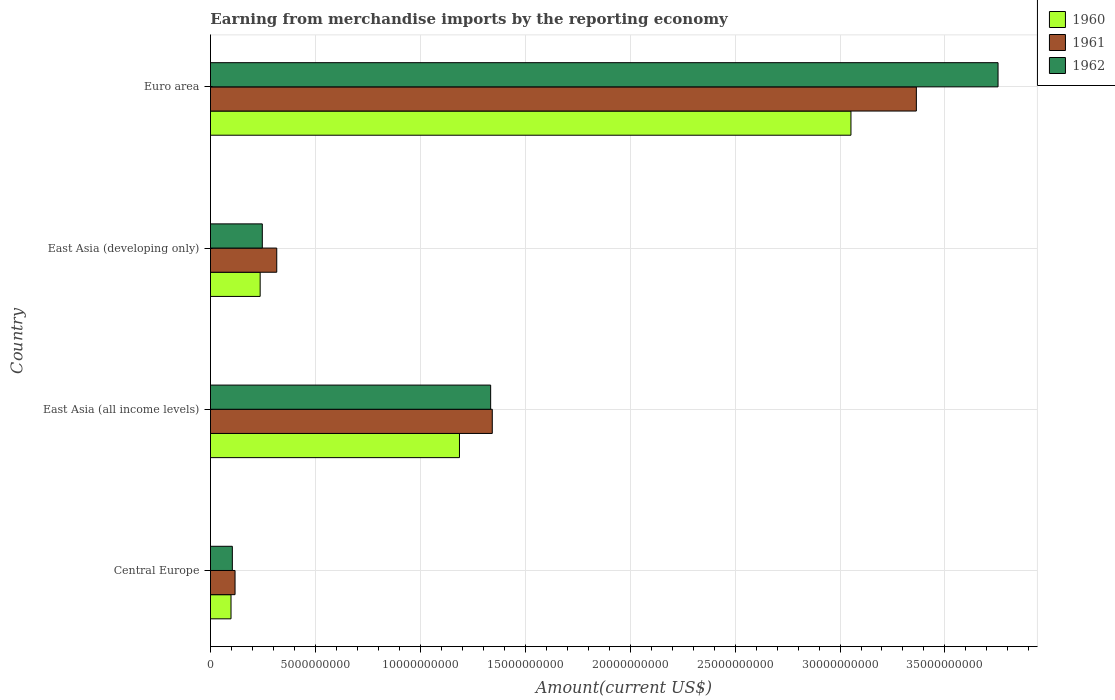How many groups of bars are there?
Provide a succinct answer. 4. How many bars are there on the 4th tick from the top?
Keep it short and to the point. 3. What is the label of the 4th group of bars from the top?
Make the answer very short. Central Europe. What is the amount earned from merchandise imports in 1961 in Euro area?
Ensure brevity in your answer.  3.36e+1. Across all countries, what is the maximum amount earned from merchandise imports in 1960?
Your answer should be compact. 3.05e+1. Across all countries, what is the minimum amount earned from merchandise imports in 1961?
Provide a short and direct response. 1.17e+09. In which country was the amount earned from merchandise imports in 1961 maximum?
Your response must be concise. Euro area. In which country was the amount earned from merchandise imports in 1960 minimum?
Keep it short and to the point. Central Europe. What is the total amount earned from merchandise imports in 1960 in the graph?
Give a very brief answer. 4.57e+1. What is the difference between the amount earned from merchandise imports in 1962 in East Asia (all income levels) and that in East Asia (developing only)?
Make the answer very short. 1.09e+1. What is the difference between the amount earned from merchandise imports in 1962 in Euro area and the amount earned from merchandise imports in 1961 in East Asia (developing only)?
Your answer should be compact. 3.44e+1. What is the average amount earned from merchandise imports in 1962 per country?
Give a very brief answer. 1.36e+1. What is the difference between the amount earned from merchandise imports in 1962 and amount earned from merchandise imports in 1961 in East Asia (all income levels)?
Ensure brevity in your answer.  -7.72e+07. In how many countries, is the amount earned from merchandise imports in 1961 greater than 23000000000 US$?
Provide a short and direct response. 1. What is the ratio of the amount earned from merchandise imports in 1961 in Central Europe to that in East Asia (all income levels)?
Your answer should be compact. 0.09. Is the amount earned from merchandise imports in 1961 in Central Europe less than that in East Asia (all income levels)?
Keep it short and to the point. Yes. Is the difference between the amount earned from merchandise imports in 1962 in Central Europe and Euro area greater than the difference between the amount earned from merchandise imports in 1961 in Central Europe and Euro area?
Provide a succinct answer. No. What is the difference between the highest and the second highest amount earned from merchandise imports in 1962?
Keep it short and to the point. 2.42e+1. What is the difference between the highest and the lowest amount earned from merchandise imports in 1962?
Your response must be concise. 3.65e+1. In how many countries, is the amount earned from merchandise imports in 1961 greater than the average amount earned from merchandise imports in 1961 taken over all countries?
Make the answer very short. 2. What does the 3rd bar from the top in Central Europe represents?
Give a very brief answer. 1960. What does the 1st bar from the bottom in Euro area represents?
Keep it short and to the point. 1960. Is it the case that in every country, the sum of the amount earned from merchandise imports in 1960 and amount earned from merchandise imports in 1962 is greater than the amount earned from merchandise imports in 1961?
Your answer should be compact. Yes. How many bars are there?
Keep it short and to the point. 12. Are all the bars in the graph horizontal?
Your answer should be compact. Yes. Does the graph contain any zero values?
Your answer should be very brief. No. Does the graph contain grids?
Provide a short and direct response. Yes. How many legend labels are there?
Make the answer very short. 3. How are the legend labels stacked?
Make the answer very short. Vertical. What is the title of the graph?
Ensure brevity in your answer.  Earning from merchandise imports by the reporting economy. Does "1960" appear as one of the legend labels in the graph?
Offer a very short reply. Yes. What is the label or title of the X-axis?
Provide a succinct answer. Amount(current US$). What is the label or title of the Y-axis?
Your response must be concise. Country. What is the Amount(current US$) of 1960 in Central Europe?
Provide a short and direct response. 9.79e+08. What is the Amount(current US$) in 1961 in Central Europe?
Ensure brevity in your answer.  1.17e+09. What is the Amount(current US$) in 1962 in Central Europe?
Give a very brief answer. 1.04e+09. What is the Amount(current US$) in 1960 in East Asia (all income levels)?
Ensure brevity in your answer.  1.19e+1. What is the Amount(current US$) in 1961 in East Asia (all income levels)?
Your answer should be compact. 1.34e+1. What is the Amount(current US$) of 1962 in East Asia (all income levels)?
Provide a succinct answer. 1.34e+1. What is the Amount(current US$) in 1960 in East Asia (developing only)?
Ensure brevity in your answer.  2.37e+09. What is the Amount(current US$) of 1961 in East Asia (developing only)?
Provide a succinct answer. 3.16e+09. What is the Amount(current US$) of 1962 in East Asia (developing only)?
Make the answer very short. 2.47e+09. What is the Amount(current US$) of 1960 in Euro area?
Make the answer very short. 3.05e+1. What is the Amount(current US$) in 1961 in Euro area?
Make the answer very short. 3.36e+1. What is the Amount(current US$) of 1962 in Euro area?
Your answer should be very brief. 3.75e+1. Across all countries, what is the maximum Amount(current US$) in 1960?
Provide a succinct answer. 3.05e+1. Across all countries, what is the maximum Amount(current US$) of 1961?
Provide a succinct answer. 3.36e+1. Across all countries, what is the maximum Amount(current US$) of 1962?
Make the answer very short. 3.75e+1. Across all countries, what is the minimum Amount(current US$) of 1960?
Offer a very short reply. 9.79e+08. Across all countries, what is the minimum Amount(current US$) in 1961?
Make the answer very short. 1.17e+09. Across all countries, what is the minimum Amount(current US$) in 1962?
Provide a succinct answer. 1.04e+09. What is the total Amount(current US$) of 1960 in the graph?
Your response must be concise. 4.57e+1. What is the total Amount(current US$) in 1961 in the graph?
Your answer should be compact. 5.14e+1. What is the total Amount(current US$) of 1962 in the graph?
Your response must be concise. 5.44e+1. What is the difference between the Amount(current US$) of 1960 in Central Europe and that in East Asia (all income levels)?
Provide a short and direct response. -1.09e+1. What is the difference between the Amount(current US$) in 1961 in Central Europe and that in East Asia (all income levels)?
Offer a very short reply. -1.23e+1. What is the difference between the Amount(current US$) of 1962 in Central Europe and that in East Asia (all income levels)?
Provide a succinct answer. -1.23e+1. What is the difference between the Amount(current US$) of 1960 in Central Europe and that in East Asia (developing only)?
Your response must be concise. -1.39e+09. What is the difference between the Amount(current US$) of 1961 in Central Europe and that in East Asia (developing only)?
Ensure brevity in your answer.  -1.99e+09. What is the difference between the Amount(current US$) in 1962 in Central Europe and that in East Asia (developing only)?
Provide a short and direct response. -1.43e+09. What is the difference between the Amount(current US$) in 1960 in Central Europe and that in Euro area?
Your answer should be compact. -2.95e+1. What is the difference between the Amount(current US$) in 1961 in Central Europe and that in Euro area?
Offer a very short reply. -3.25e+1. What is the difference between the Amount(current US$) of 1962 in Central Europe and that in Euro area?
Offer a terse response. -3.65e+1. What is the difference between the Amount(current US$) in 1960 in East Asia (all income levels) and that in East Asia (developing only)?
Your answer should be compact. 9.50e+09. What is the difference between the Amount(current US$) in 1961 in East Asia (all income levels) and that in East Asia (developing only)?
Your response must be concise. 1.03e+1. What is the difference between the Amount(current US$) in 1962 in East Asia (all income levels) and that in East Asia (developing only)?
Ensure brevity in your answer.  1.09e+1. What is the difference between the Amount(current US$) of 1960 in East Asia (all income levels) and that in Euro area?
Your answer should be compact. -1.87e+1. What is the difference between the Amount(current US$) in 1961 in East Asia (all income levels) and that in Euro area?
Make the answer very short. -2.02e+1. What is the difference between the Amount(current US$) of 1962 in East Asia (all income levels) and that in Euro area?
Make the answer very short. -2.42e+1. What is the difference between the Amount(current US$) of 1960 in East Asia (developing only) and that in Euro area?
Give a very brief answer. -2.82e+1. What is the difference between the Amount(current US$) in 1961 in East Asia (developing only) and that in Euro area?
Give a very brief answer. -3.05e+1. What is the difference between the Amount(current US$) of 1962 in East Asia (developing only) and that in Euro area?
Keep it short and to the point. -3.51e+1. What is the difference between the Amount(current US$) of 1960 in Central Europe and the Amount(current US$) of 1961 in East Asia (all income levels)?
Your answer should be very brief. -1.24e+1. What is the difference between the Amount(current US$) of 1960 in Central Europe and the Amount(current US$) of 1962 in East Asia (all income levels)?
Your answer should be compact. -1.24e+1. What is the difference between the Amount(current US$) in 1961 in Central Europe and the Amount(current US$) in 1962 in East Asia (all income levels)?
Provide a succinct answer. -1.22e+1. What is the difference between the Amount(current US$) in 1960 in Central Europe and the Amount(current US$) in 1961 in East Asia (developing only)?
Provide a succinct answer. -2.18e+09. What is the difference between the Amount(current US$) in 1960 in Central Europe and the Amount(current US$) in 1962 in East Asia (developing only)?
Your response must be concise. -1.49e+09. What is the difference between the Amount(current US$) of 1961 in Central Europe and the Amount(current US$) of 1962 in East Asia (developing only)?
Your response must be concise. -1.30e+09. What is the difference between the Amount(current US$) of 1960 in Central Europe and the Amount(current US$) of 1961 in Euro area?
Provide a succinct answer. -3.27e+1. What is the difference between the Amount(current US$) of 1960 in Central Europe and the Amount(current US$) of 1962 in Euro area?
Ensure brevity in your answer.  -3.66e+1. What is the difference between the Amount(current US$) in 1961 in Central Europe and the Amount(current US$) in 1962 in Euro area?
Offer a terse response. -3.64e+1. What is the difference between the Amount(current US$) in 1960 in East Asia (all income levels) and the Amount(current US$) in 1961 in East Asia (developing only)?
Offer a very short reply. 8.71e+09. What is the difference between the Amount(current US$) of 1960 in East Asia (all income levels) and the Amount(current US$) of 1962 in East Asia (developing only)?
Make the answer very short. 9.40e+09. What is the difference between the Amount(current US$) of 1961 in East Asia (all income levels) and the Amount(current US$) of 1962 in East Asia (developing only)?
Offer a terse response. 1.10e+1. What is the difference between the Amount(current US$) in 1960 in East Asia (all income levels) and the Amount(current US$) in 1961 in Euro area?
Keep it short and to the point. -2.18e+1. What is the difference between the Amount(current US$) of 1960 in East Asia (all income levels) and the Amount(current US$) of 1962 in Euro area?
Your response must be concise. -2.57e+1. What is the difference between the Amount(current US$) of 1961 in East Asia (all income levels) and the Amount(current US$) of 1962 in Euro area?
Your answer should be compact. -2.41e+1. What is the difference between the Amount(current US$) of 1960 in East Asia (developing only) and the Amount(current US$) of 1961 in Euro area?
Provide a short and direct response. -3.13e+1. What is the difference between the Amount(current US$) in 1960 in East Asia (developing only) and the Amount(current US$) in 1962 in Euro area?
Provide a short and direct response. -3.52e+1. What is the difference between the Amount(current US$) of 1961 in East Asia (developing only) and the Amount(current US$) of 1962 in Euro area?
Your answer should be compact. -3.44e+1. What is the average Amount(current US$) of 1960 per country?
Your answer should be compact. 1.14e+1. What is the average Amount(current US$) in 1961 per country?
Your response must be concise. 1.28e+1. What is the average Amount(current US$) in 1962 per country?
Offer a very short reply. 1.36e+1. What is the difference between the Amount(current US$) of 1960 and Amount(current US$) of 1961 in Central Europe?
Your answer should be compact. -1.92e+08. What is the difference between the Amount(current US$) in 1960 and Amount(current US$) in 1962 in Central Europe?
Ensure brevity in your answer.  -6.33e+07. What is the difference between the Amount(current US$) in 1961 and Amount(current US$) in 1962 in Central Europe?
Make the answer very short. 1.28e+08. What is the difference between the Amount(current US$) of 1960 and Amount(current US$) of 1961 in East Asia (all income levels)?
Your answer should be compact. -1.56e+09. What is the difference between the Amount(current US$) of 1960 and Amount(current US$) of 1962 in East Asia (all income levels)?
Keep it short and to the point. -1.49e+09. What is the difference between the Amount(current US$) in 1961 and Amount(current US$) in 1962 in East Asia (all income levels)?
Your answer should be compact. 7.72e+07. What is the difference between the Amount(current US$) in 1960 and Amount(current US$) in 1961 in East Asia (developing only)?
Provide a short and direct response. -7.90e+08. What is the difference between the Amount(current US$) in 1960 and Amount(current US$) in 1962 in East Asia (developing only)?
Keep it short and to the point. -1.03e+08. What is the difference between the Amount(current US$) of 1961 and Amount(current US$) of 1962 in East Asia (developing only)?
Provide a short and direct response. 6.88e+08. What is the difference between the Amount(current US$) of 1960 and Amount(current US$) of 1961 in Euro area?
Provide a short and direct response. -3.12e+09. What is the difference between the Amount(current US$) in 1960 and Amount(current US$) in 1962 in Euro area?
Give a very brief answer. -7.01e+09. What is the difference between the Amount(current US$) of 1961 and Amount(current US$) of 1962 in Euro area?
Your response must be concise. -3.89e+09. What is the ratio of the Amount(current US$) of 1960 in Central Europe to that in East Asia (all income levels)?
Make the answer very short. 0.08. What is the ratio of the Amount(current US$) in 1961 in Central Europe to that in East Asia (all income levels)?
Make the answer very short. 0.09. What is the ratio of the Amount(current US$) of 1962 in Central Europe to that in East Asia (all income levels)?
Provide a succinct answer. 0.08. What is the ratio of the Amount(current US$) in 1960 in Central Europe to that in East Asia (developing only)?
Provide a short and direct response. 0.41. What is the ratio of the Amount(current US$) of 1961 in Central Europe to that in East Asia (developing only)?
Provide a short and direct response. 0.37. What is the ratio of the Amount(current US$) of 1962 in Central Europe to that in East Asia (developing only)?
Your answer should be compact. 0.42. What is the ratio of the Amount(current US$) in 1960 in Central Europe to that in Euro area?
Your answer should be compact. 0.03. What is the ratio of the Amount(current US$) of 1961 in Central Europe to that in Euro area?
Provide a short and direct response. 0.03. What is the ratio of the Amount(current US$) of 1962 in Central Europe to that in Euro area?
Provide a succinct answer. 0.03. What is the ratio of the Amount(current US$) in 1960 in East Asia (all income levels) to that in East Asia (developing only)?
Your response must be concise. 5.01. What is the ratio of the Amount(current US$) in 1961 in East Asia (all income levels) to that in East Asia (developing only)?
Give a very brief answer. 4.25. What is the ratio of the Amount(current US$) of 1962 in East Asia (all income levels) to that in East Asia (developing only)?
Your answer should be compact. 5.4. What is the ratio of the Amount(current US$) of 1960 in East Asia (all income levels) to that in Euro area?
Keep it short and to the point. 0.39. What is the ratio of the Amount(current US$) in 1961 in East Asia (all income levels) to that in Euro area?
Provide a short and direct response. 0.4. What is the ratio of the Amount(current US$) in 1962 in East Asia (all income levels) to that in Euro area?
Your answer should be very brief. 0.36. What is the ratio of the Amount(current US$) in 1960 in East Asia (developing only) to that in Euro area?
Your response must be concise. 0.08. What is the ratio of the Amount(current US$) of 1961 in East Asia (developing only) to that in Euro area?
Give a very brief answer. 0.09. What is the ratio of the Amount(current US$) of 1962 in East Asia (developing only) to that in Euro area?
Your answer should be compact. 0.07. What is the difference between the highest and the second highest Amount(current US$) of 1960?
Your answer should be compact. 1.87e+1. What is the difference between the highest and the second highest Amount(current US$) in 1961?
Your answer should be very brief. 2.02e+1. What is the difference between the highest and the second highest Amount(current US$) in 1962?
Your answer should be compact. 2.42e+1. What is the difference between the highest and the lowest Amount(current US$) in 1960?
Your answer should be compact. 2.95e+1. What is the difference between the highest and the lowest Amount(current US$) in 1961?
Make the answer very short. 3.25e+1. What is the difference between the highest and the lowest Amount(current US$) in 1962?
Offer a terse response. 3.65e+1. 